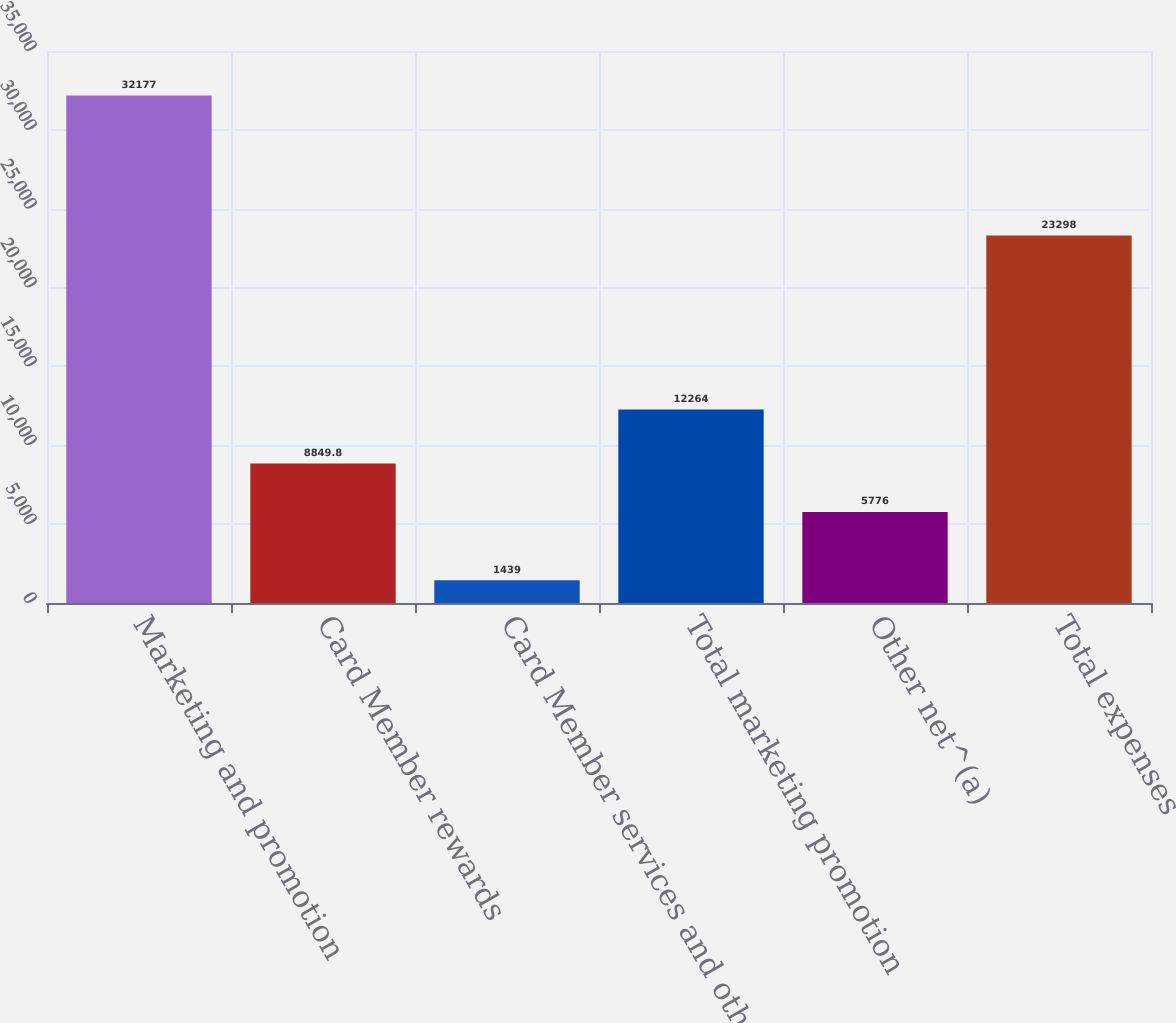Convert chart. <chart><loc_0><loc_0><loc_500><loc_500><bar_chart><fcel>Marketing and promotion<fcel>Card Member rewards<fcel>Card Member services and other<fcel>Total marketing promotion<fcel>Other net^(a)<fcel>Total expenses<nl><fcel>32177<fcel>8849.8<fcel>1439<fcel>12264<fcel>5776<fcel>23298<nl></chart> 